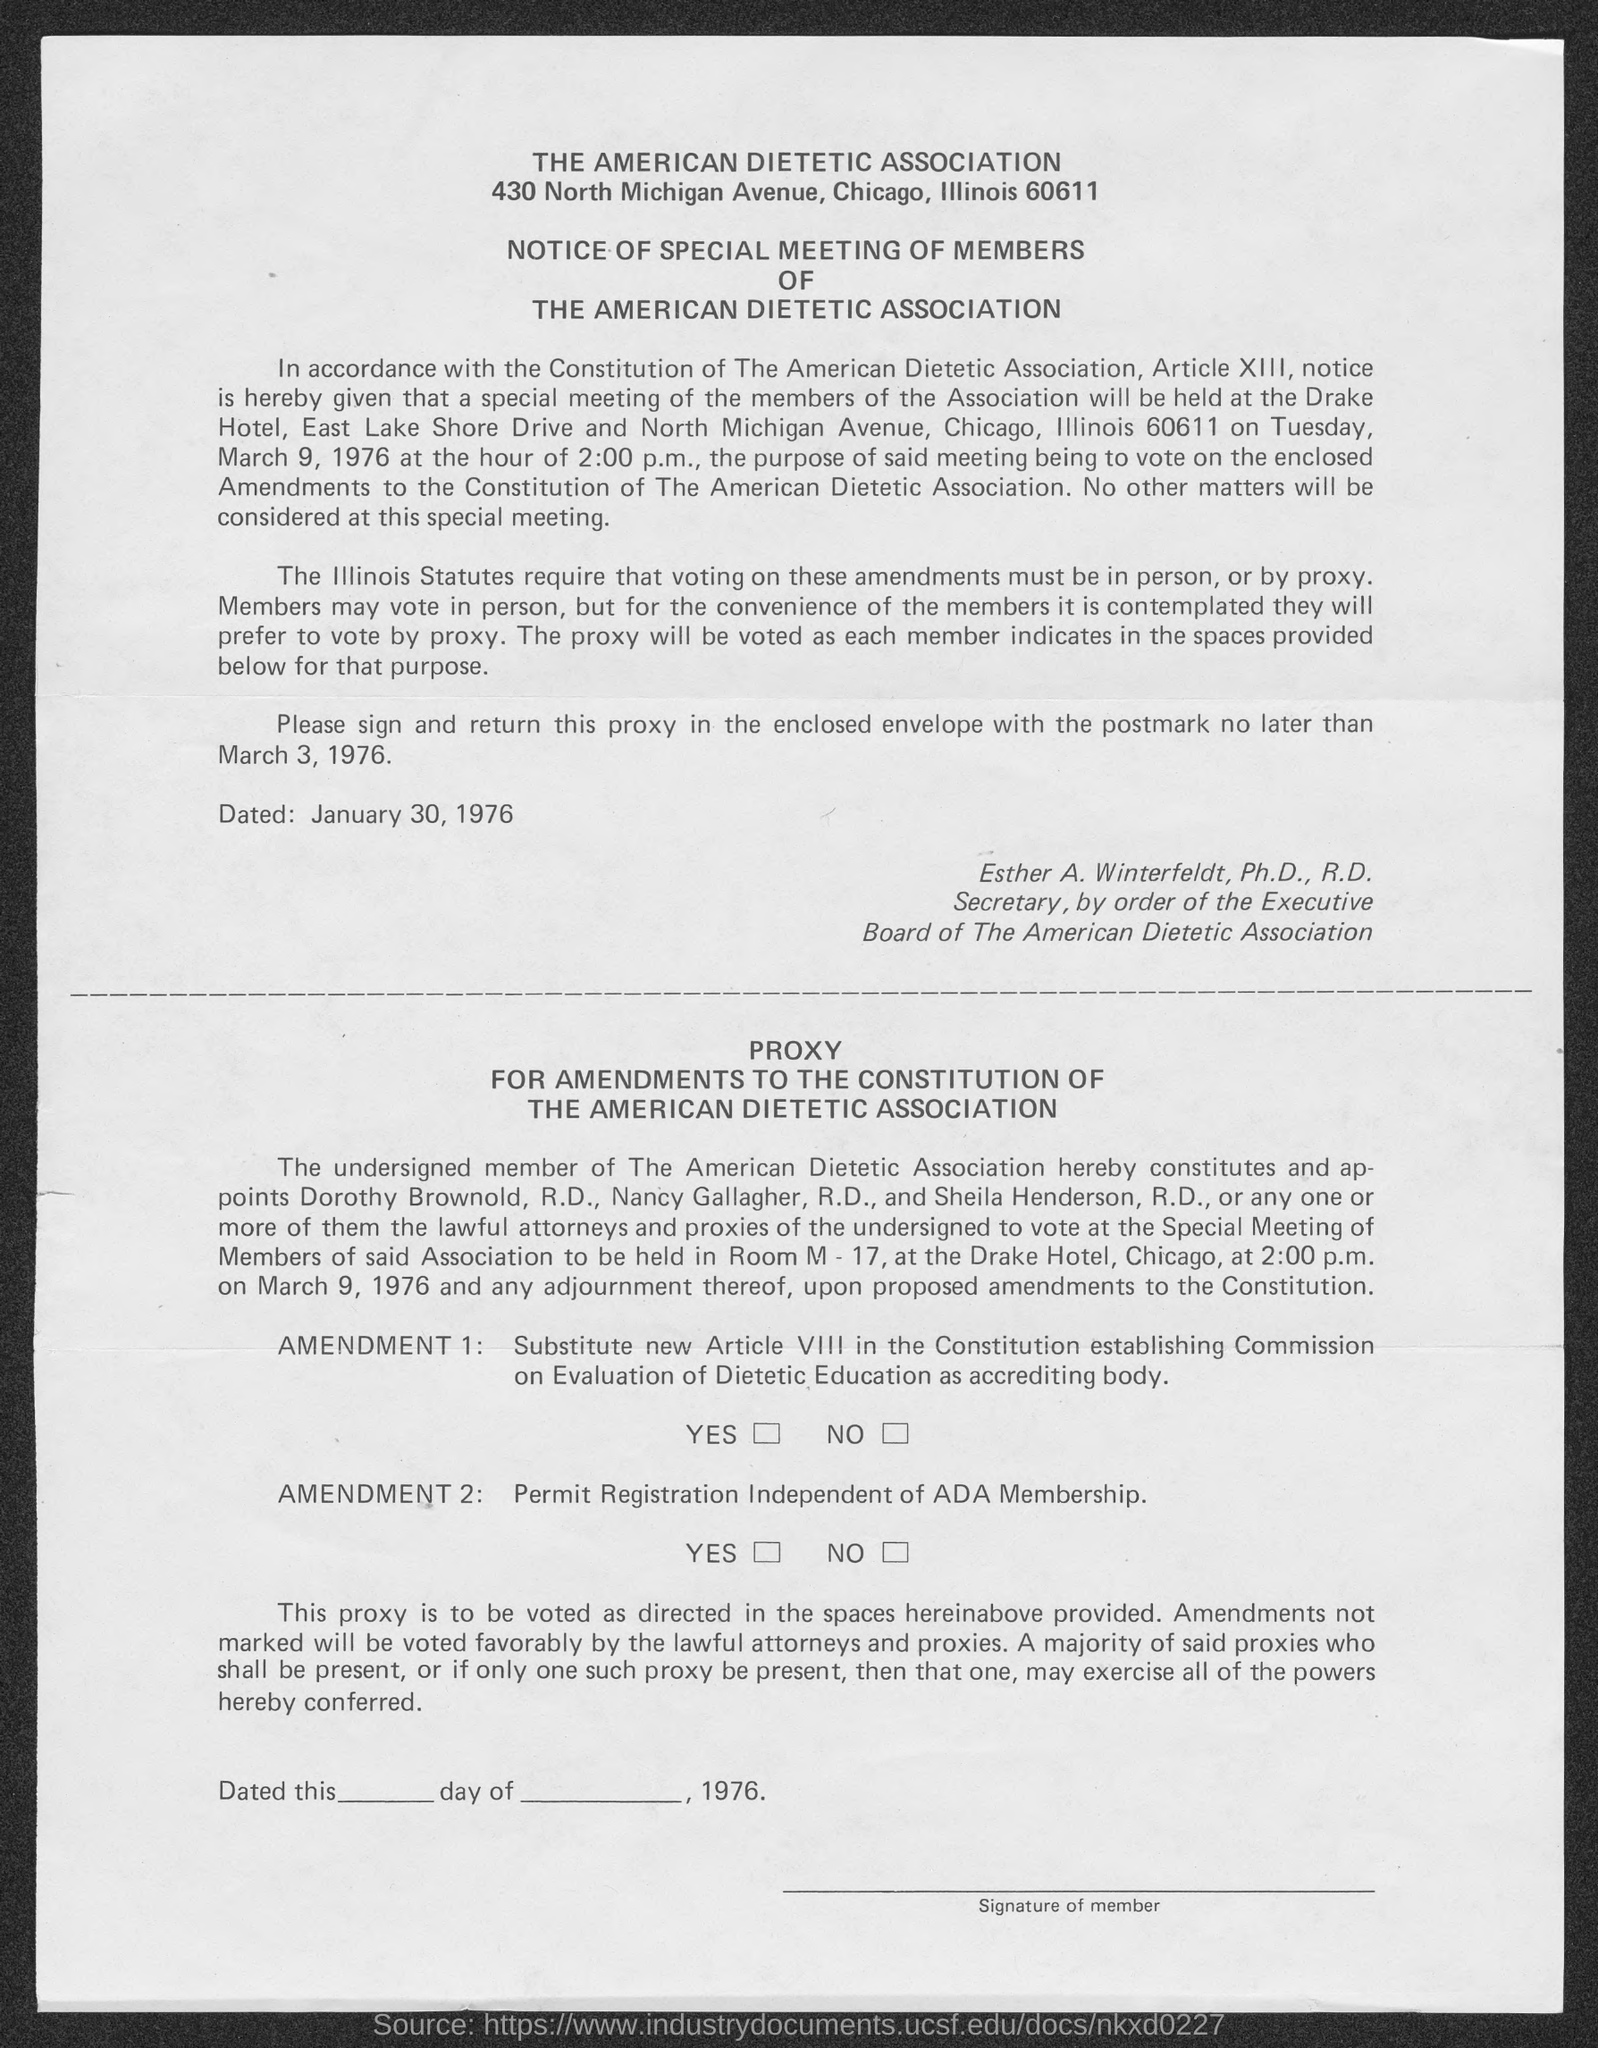List a handful of essential elements in this visual. The first title in the document is "The American Dietetic Association. Esther A. Winterfeldt, Ph.D., R.D., is the secretary of the board of the American Dietetic Association. 